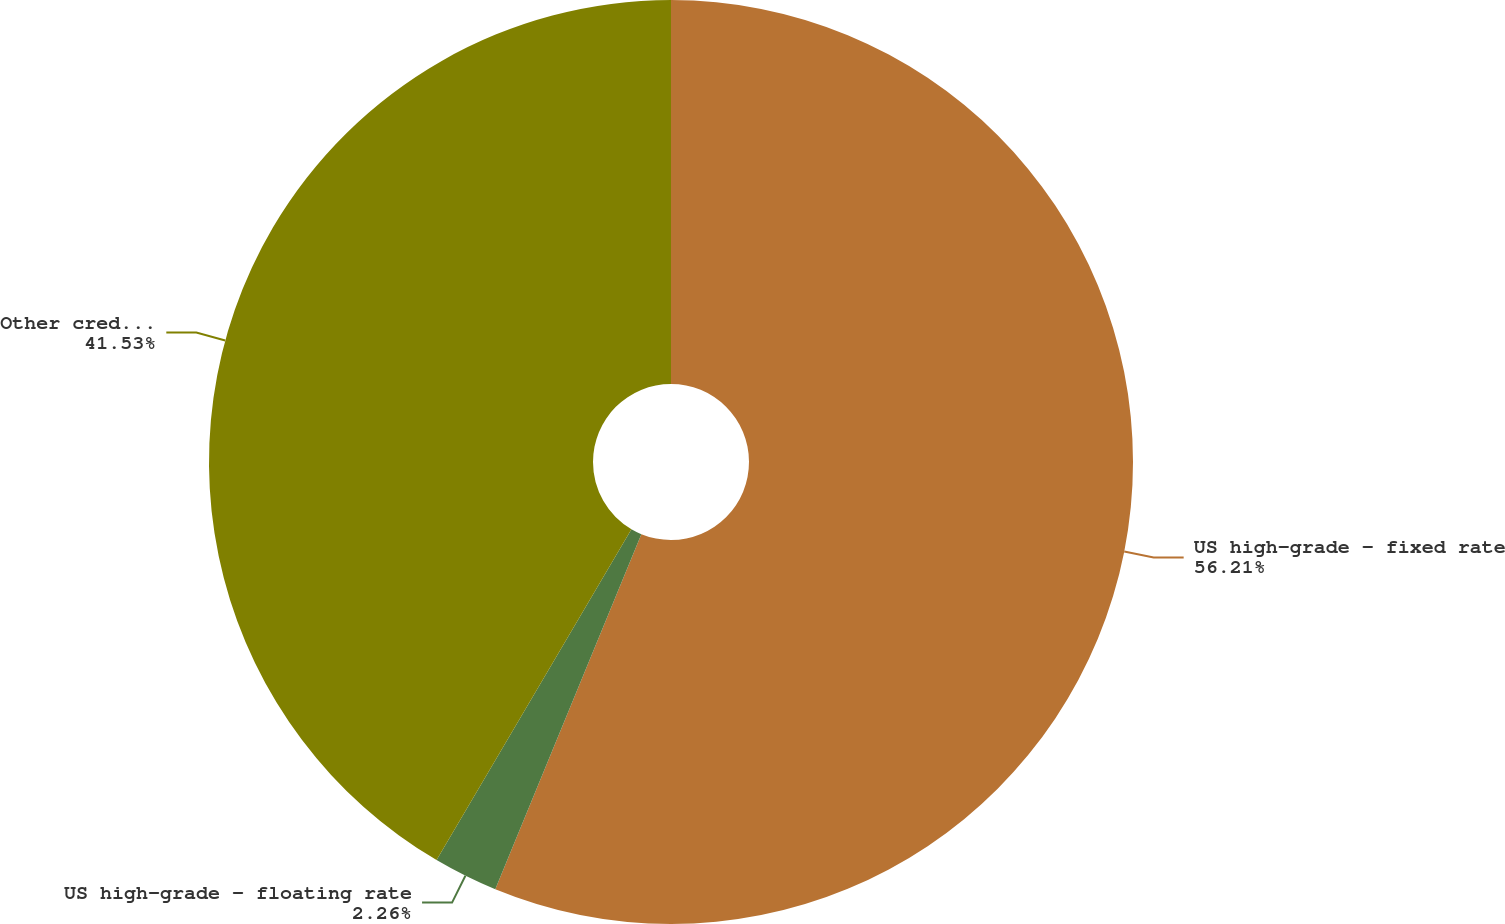Convert chart to OTSL. <chart><loc_0><loc_0><loc_500><loc_500><pie_chart><fcel>US high-grade - fixed rate<fcel>US high-grade - floating rate<fcel>Other credit Liquid products<nl><fcel>56.21%<fcel>2.26%<fcel>41.53%<nl></chart> 